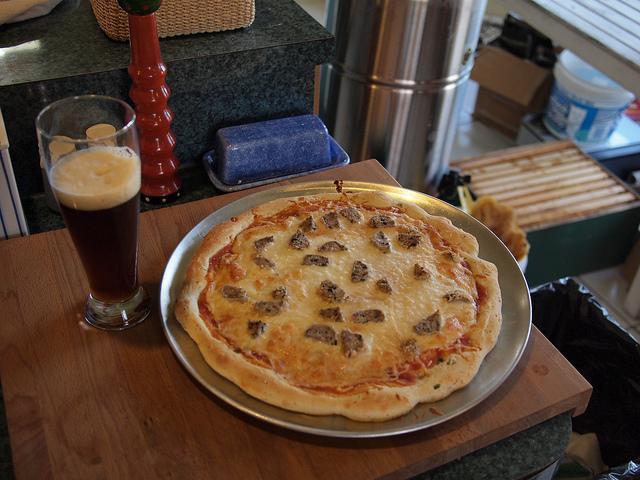How many toppings are on the pizza?
Give a very brief answer. 1. How many people are facing the camera?
Give a very brief answer. 0. 